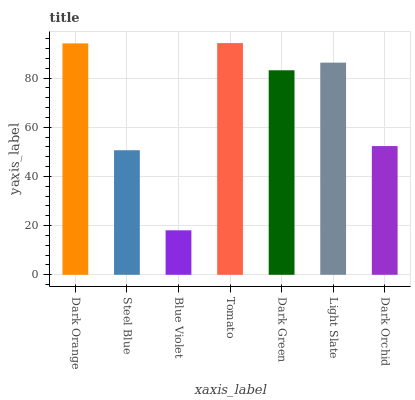Is Steel Blue the minimum?
Answer yes or no. No. Is Steel Blue the maximum?
Answer yes or no. No. Is Dark Orange greater than Steel Blue?
Answer yes or no. Yes. Is Steel Blue less than Dark Orange?
Answer yes or no. Yes. Is Steel Blue greater than Dark Orange?
Answer yes or no. No. Is Dark Orange less than Steel Blue?
Answer yes or no. No. Is Dark Green the high median?
Answer yes or no. Yes. Is Dark Green the low median?
Answer yes or no. Yes. Is Dark Orchid the high median?
Answer yes or no. No. Is Blue Violet the low median?
Answer yes or no. No. 